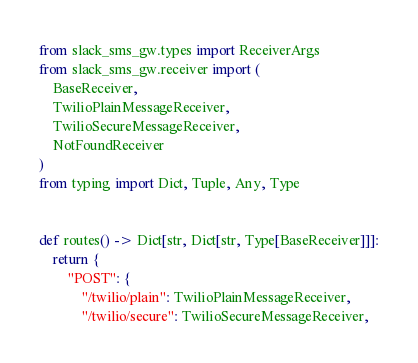<code> <loc_0><loc_0><loc_500><loc_500><_Python_>from slack_sms_gw.types import ReceiverArgs
from slack_sms_gw.receiver import (
    BaseReceiver,
    TwilioPlainMessageReceiver,
    TwilioSecureMessageReceiver,
    NotFoundReceiver
)
from typing import Dict, Tuple, Any, Type


def routes() -> Dict[str, Dict[str, Type[BaseReceiver]]]:
    return {
        "POST": {
            "/twilio/plain": TwilioPlainMessageReceiver,
            "/twilio/secure": TwilioSecureMessageReceiver,</code> 